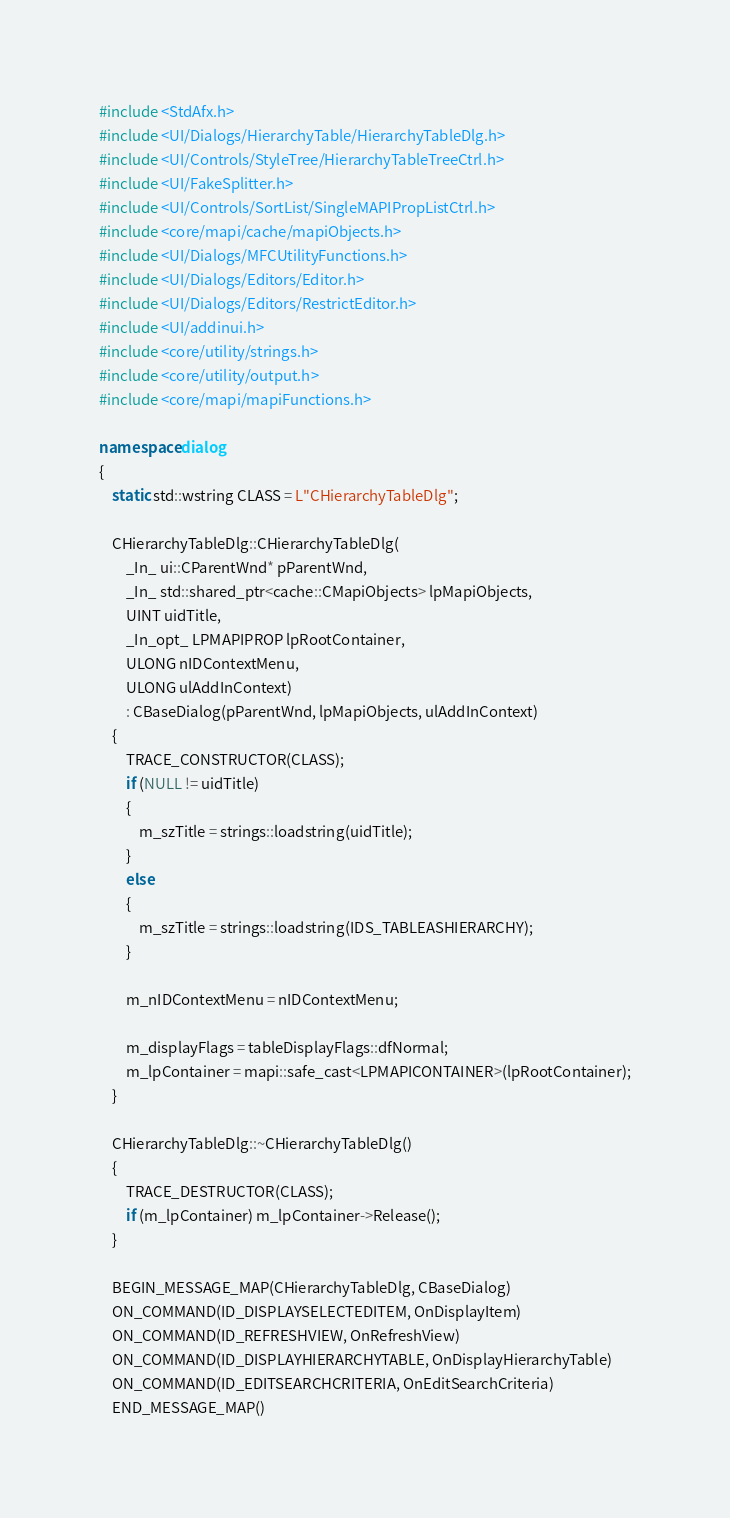Convert code to text. <code><loc_0><loc_0><loc_500><loc_500><_C++_>#include <StdAfx.h>
#include <UI/Dialogs/HierarchyTable/HierarchyTableDlg.h>
#include <UI/Controls/StyleTree/HierarchyTableTreeCtrl.h>
#include <UI/FakeSplitter.h>
#include <UI/Controls/SortList/SingleMAPIPropListCtrl.h>
#include <core/mapi/cache/mapiObjects.h>
#include <UI/Dialogs/MFCUtilityFunctions.h>
#include <UI/Dialogs/Editors/Editor.h>
#include <UI/Dialogs/Editors/RestrictEditor.h>
#include <UI/addinui.h>
#include <core/utility/strings.h>
#include <core/utility/output.h>
#include <core/mapi/mapiFunctions.h>

namespace dialog
{
	static std::wstring CLASS = L"CHierarchyTableDlg";

	CHierarchyTableDlg::CHierarchyTableDlg(
		_In_ ui::CParentWnd* pParentWnd,
		_In_ std::shared_ptr<cache::CMapiObjects> lpMapiObjects,
		UINT uidTitle,
		_In_opt_ LPMAPIPROP lpRootContainer,
		ULONG nIDContextMenu,
		ULONG ulAddInContext)
		: CBaseDialog(pParentWnd, lpMapiObjects, ulAddInContext)
	{
		TRACE_CONSTRUCTOR(CLASS);
		if (NULL != uidTitle)
		{
			m_szTitle = strings::loadstring(uidTitle);
		}
		else
		{
			m_szTitle = strings::loadstring(IDS_TABLEASHIERARCHY);
		}

		m_nIDContextMenu = nIDContextMenu;

		m_displayFlags = tableDisplayFlags::dfNormal;
		m_lpContainer = mapi::safe_cast<LPMAPICONTAINER>(lpRootContainer);
	}

	CHierarchyTableDlg::~CHierarchyTableDlg()
	{
		TRACE_DESTRUCTOR(CLASS);
		if (m_lpContainer) m_lpContainer->Release();
	}

	BEGIN_MESSAGE_MAP(CHierarchyTableDlg, CBaseDialog)
	ON_COMMAND(ID_DISPLAYSELECTEDITEM, OnDisplayItem)
	ON_COMMAND(ID_REFRESHVIEW, OnRefreshView)
	ON_COMMAND(ID_DISPLAYHIERARCHYTABLE, OnDisplayHierarchyTable)
	ON_COMMAND(ID_EDITSEARCHCRITERIA, OnEditSearchCriteria)
	END_MESSAGE_MAP()
</code> 